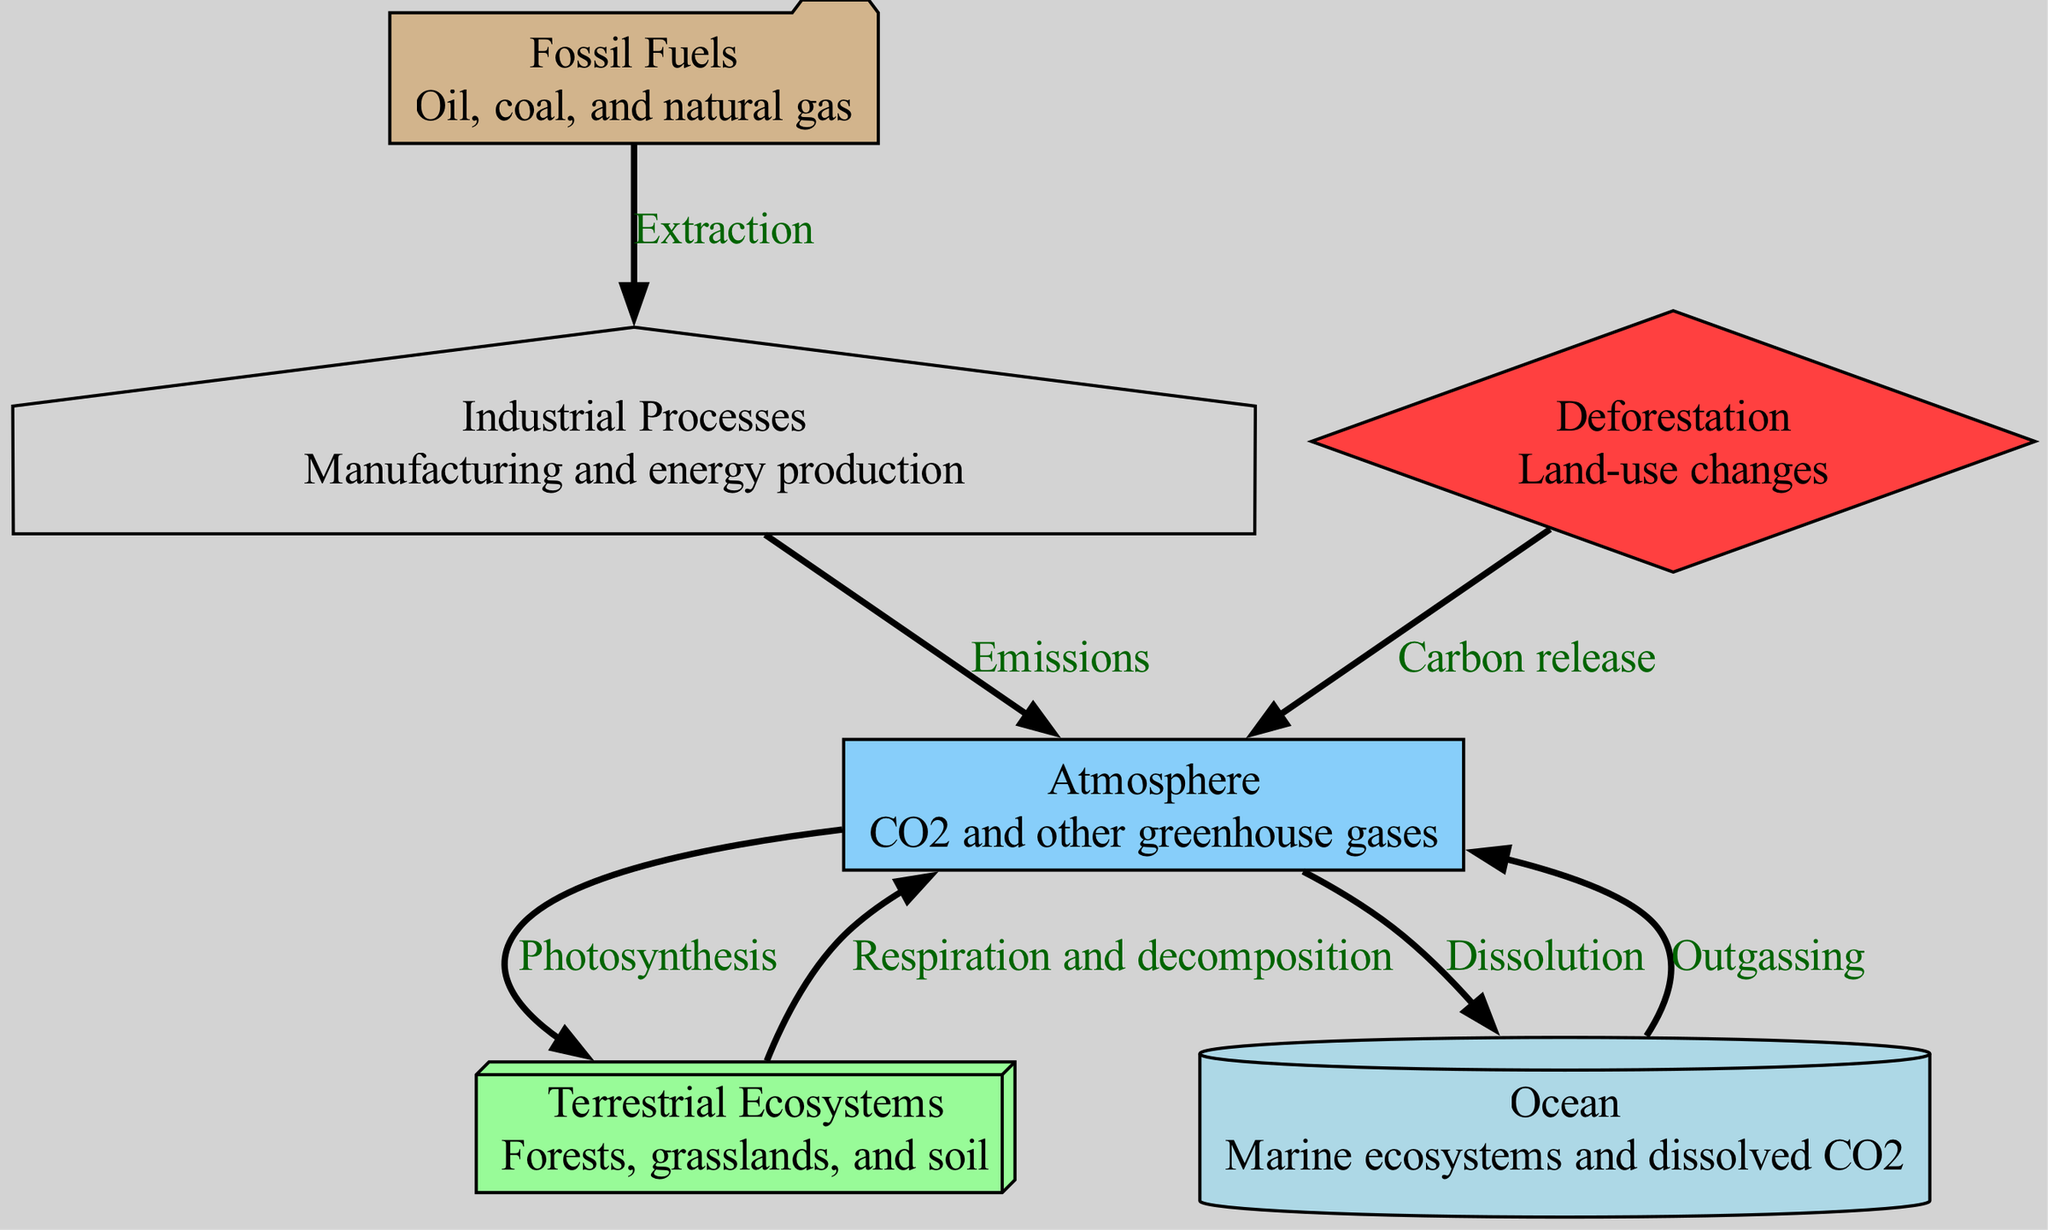What are the two main cycles shown in the diagram? The diagram illustrates two main cycles: the flow of carbon from the atmosphere to terrestrial ecosystems through photosynthesis and the respiration and decomposition flow back into the atmosphere.
Answer: Photosynthesis and respiration How many nodes are present in the diagram? By counting the unique entities depicted in the diagram, we identify that there are a total of six nodes: atmosphere, terrestrial ecosystems, ocean, fossil fuels, industrial processes, and deforestation.
Answer: Six What type of ecosystems are represented in the ocean node? The ocean node specifically represents marine ecosystems and the dissolved carbon dioxide within them, highlighting the role of oceans in the carbon cycle.
Answer: Marine ecosystems Which process connects fossil fuels to industrial processes? The connection from fossil fuels to industrial processes is established by the extraction process, indicating how fossil fuels are sourced for industrial activities.
Answer: Extraction What is the impact of deforestation as shown in the diagram? The diagram indicates that deforestation results in carbon release, showcasing its detrimental effect on carbon levels in the atmosphere and the overall carbon cycle.
Answer: Carbon release How do terrestrial ecosystems contribute back into the atmosphere? Terrestrial ecosystems send carbon back into the atmosphere primarily through the processes of respiration and decomposition, indicating biotic contributions to carbon.
Answer: Respiration and decomposition What does the label "Dissolution" signify in the context of the carbon cycle? The label "Dissolution" signifies the process by which carbon dioxide from the atmosphere is absorbed into the ocean, indicating a critical exchange of carbon between these two spheres.
Answer: Absorption of CO2 Which node is responsible for emissions in the carbon cycle? The industrial processes node is responsible for emissions, illustrating how industrial activities contribute to atmospheric greenhouse gas levels.
Answer: Industrial processes 